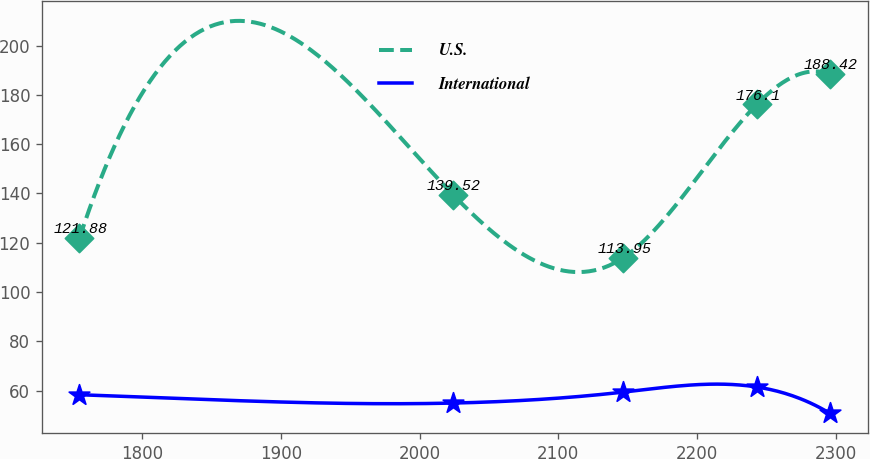Convert chart to OTSL. <chart><loc_0><loc_0><loc_500><loc_500><line_chart><ecel><fcel>U.S.<fcel>International<nl><fcel>1754.62<fcel>121.88<fcel>58.36<nl><fcel>2024.07<fcel>139.52<fcel>54.98<nl><fcel>2146.96<fcel>113.95<fcel>59.43<nl><fcel>2243.16<fcel>176.1<fcel>61.5<nl><fcel>2296.05<fcel>188.42<fcel>50.77<nl></chart> 